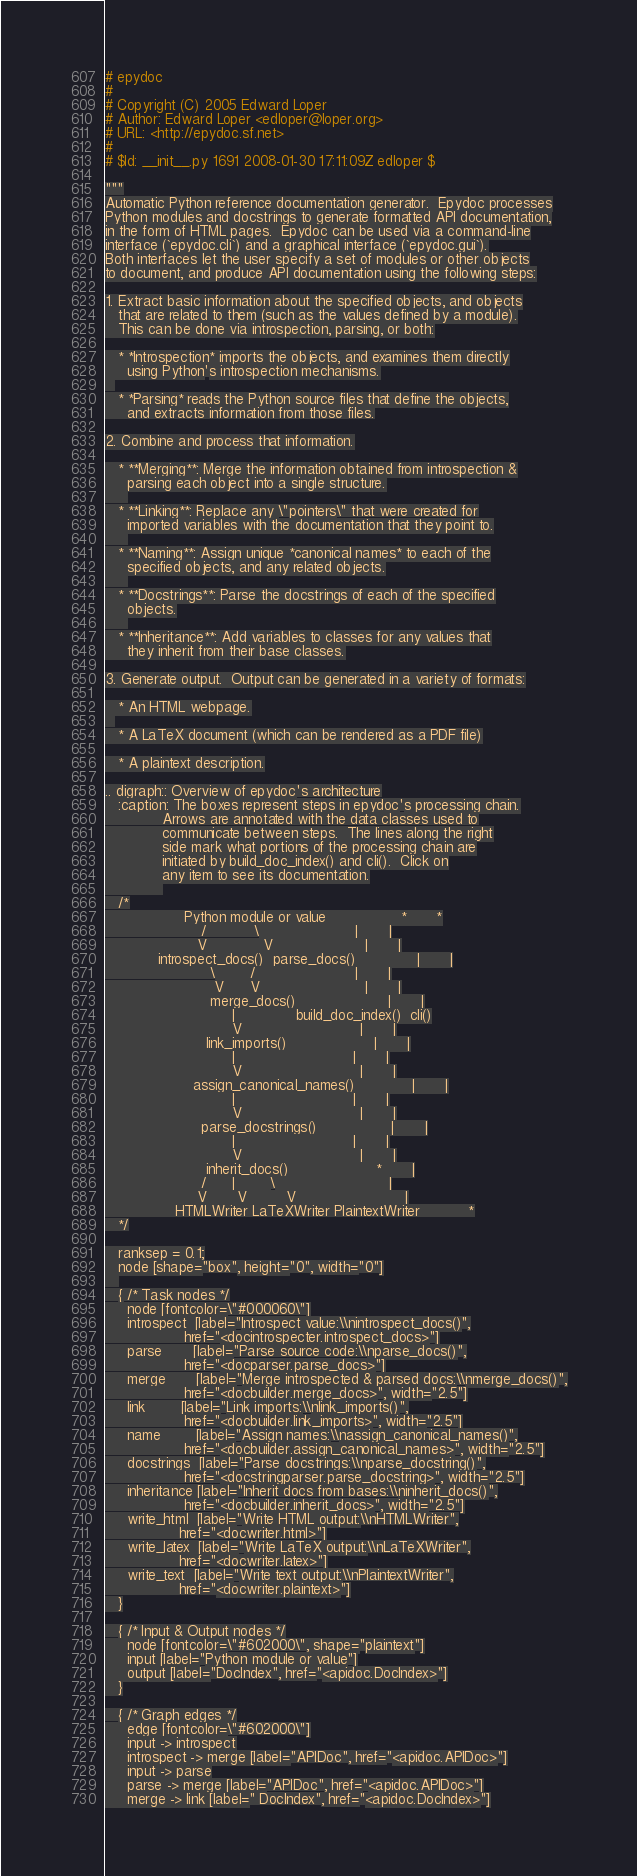<code> <loc_0><loc_0><loc_500><loc_500><_Python_># epydoc
#
# Copyright (C) 2005 Edward Loper
# Author: Edward Loper <edloper@loper.org>
# URL: <http://epydoc.sf.net>
#
# $Id: __init__.py 1691 2008-01-30 17:11:09Z edloper $

"""
Automatic Python reference documentation generator.  Epydoc processes
Python modules and docstrings to generate formatted API documentation,
in the form of HTML pages.  Epydoc can be used via a command-line
interface (`epydoc.cli`) and a graphical interface (`epydoc.gui`).
Both interfaces let the user specify a set of modules or other objects
to document, and produce API documentation using the following steps:

1. Extract basic information about the specified objects, and objects
   that are related to them (such as the values defined by a module).
   This can be done via introspection, parsing, or both:

   * *Introspection* imports the objects, and examines them directly
     using Python's introspection mechanisms.
  
   * *Parsing* reads the Python source files that define the objects,
     and extracts information from those files.

2. Combine and process that information.

   * **Merging**: Merge the information obtained from introspection &
     parsing each object into a single structure.
     
   * **Linking**: Replace any \"pointers\" that were created for
     imported variables with the documentation that they point to.
     
   * **Naming**: Assign unique *canonical names* to each of the
     specified objects, and any related objects.
     
   * **Docstrings**: Parse the docstrings of each of the specified
     objects.
     
   * **Inheritance**: Add variables to classes for any values that
     they inherit from their base classes.

3. Generate output.  Output can be generated in a variety of formats:

   * An HTML webpage.
  
   * A LaTeX document (which can be rendered as a PDF file)

   * A plaintext description.

.. digraph:: Overview of epydoc's architecture
   :caption: The boxes represent steps in epydoc's processing chain.
             Arrows are annotated with the data classes used to
             communicate between steps.  The lines along the right
             side mark what portions of the processing chain are
             initiated by build_doc_index() and cli().  Click on
             any item to see its documentation.
             
   /*
                  Python module or value                 *       *
                      /           \                      |       |
                     V             V                     |       |
            introspect_docs()  parse_docs()              |       |
                        \        /                       |       |
                         V      V                        |       |
                        merge_docs()                     |       |
                             |              build_doc_index()  cli()
                             V                           |       |
                       link_imports()                    |       |
                             |                           |       |
                             V                           |       |
                    assign_canonical_names()             |       |
                             |                           |       |
                             V                           |       |
                      parse_docstrings()                 |       |
                             |                           |       |
                             V                           |       |
                       inherit_docs()                    *       |
                      /      |        \                          |
                     V       V         V                         |
                HTMLWriter LaTeXWriter PlaintextWriter           *
   */

   ranksep = 0.1;
   node [shape="box", height="0", width="0"]
   
   { /* Task nodes */
     node [fontcolor=\"#000060\"]
     introspect  [label="Introspect value:\\nintrospect_docs()",
                  href="<docintrospecter.introspect_docs>"]
     parse       [label="Parse source code:\\nparse_docs()",
                  href="<docparser.parse_docs>"]
     merge       [label="Merge introspected & parsed docs:\\nmerge_docs()",
                  href="<docbuilder.merge_docs>", width="2.5"]
     link        [label="Link imports:\\nlink_imports()",
                  href="<docbuilder.link_imports>", width="2.5"]
     name        [label="Assign names:\\nassign_canonical_names()",
                  href="<docbuilder.assign_canonical_names>", width="2.5"]
     docstrings  [label="Parse docstrings:\\nparse_docstring()",
                  href="<docstringparser.parse_docstring>", width="2.5"]
     inheritance [label="Inherit docs from bases:\\ninherit_docs()",
                  href="<docbuilder.inherit_docs>", width="2.5"]
     write_html  [label="Write HTML output:\\nHTMLWriter",
                 href="<docwriter.html>"]
     write_latex  [label="Write LaTeX output:\\nLaTeXWriter",
                 href="<docwriter.latex>"]
     write_text  [label="Write text output:\\nPlaintextWriter",
                 href="<docwriter.plaintext>"]
   }

   { /* Input & Output nodes */
     node [fontcolor=\"#602000\", shape="plaintext"]
     input [label="Python module or value"]
     output [label="DocIndex", href="<apidoc.DocIndex>"]
   }

   { /* Graph edges */
     edge [fontcolor=\"#602000\"]
     input -> introspect
     introspect -> merge [label="APIDoc", href="<apidoc.APIDoc>"]
     input -> parse
     parse -> merge [label="APIDoc", href="<apidoc.APIDoc>"]
     merge -> link [label=" DocIndex", href="<apidoc.DocIndex>"]</code> 